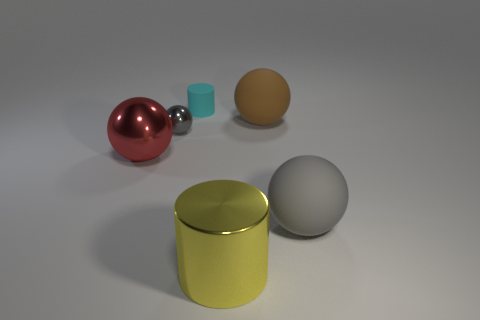There is another ball that is the same color as the tiny ball; what size is it?
Give a very brief answer. Large. There is a cyan thing that is the same material as the large brown thing; what is its size?
Ensure brevity in your answer.  Small. Is the small cyan cylinder made of the same material as the big red thing?
Give a very brief answer. No. What is the shape of the big rubber thing that is the same color as the tiny metal sphere?
Ensure brevity in your answer.  Sphere. How many big objects are yellow things or gray metallic things?
Offer a terse response. 1. There is a tiny thing that is made of the same material as the big cylinder; what shape is it?
Provide a succinct answer. Sphere. Do the small metallic object and the big yellow object have the same shape?
Provide a succinct answer. No. What color is the matte cylinder?
Your answer should be very brief. Cyan. What number of things are either cyan rubber things or yellow cubes?
Keep it short and to the point. 1. Is there anything else that is the same material as the yellow cylinder?
Your answer should be very brief. Yes. 